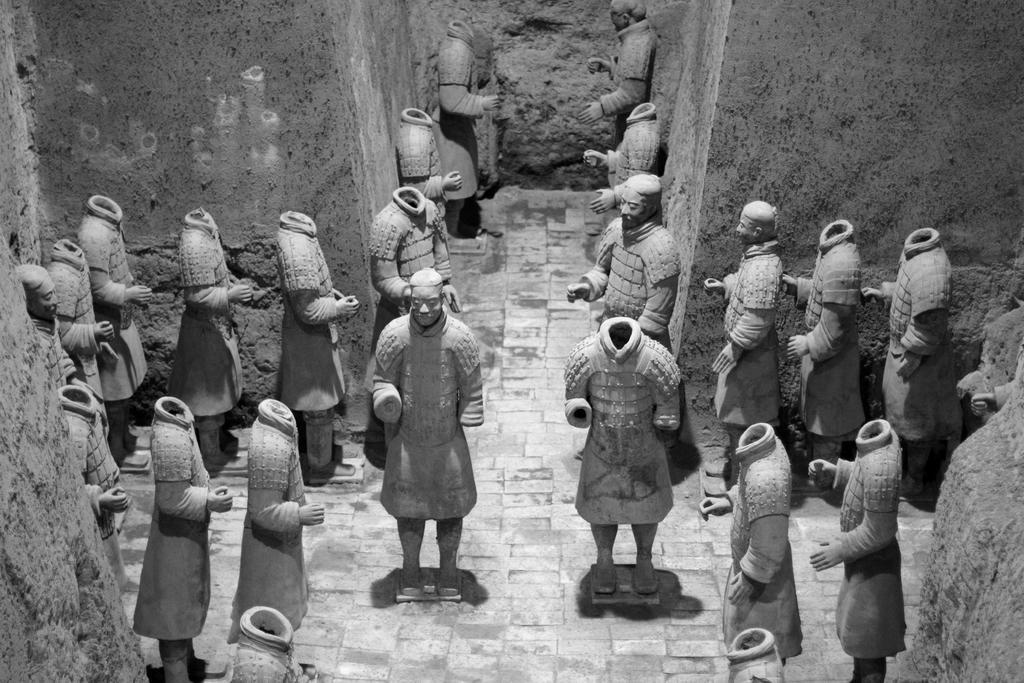How would you summarize this image in a sentence or two? In which there are so many sculptures in the room, where some have heads and some are head less. 